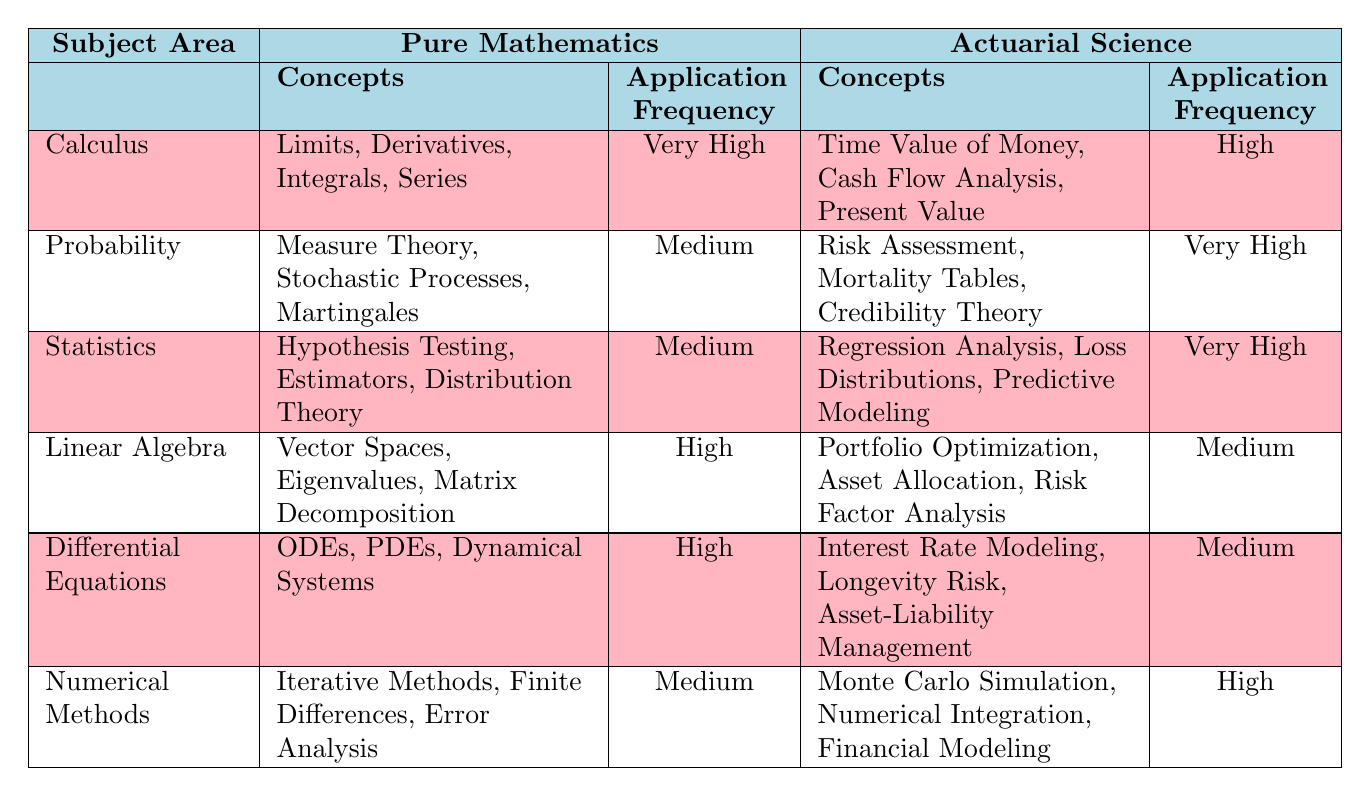What are the application frequencies of concepts in Probability under Pure Mathematics? In the table, the application frequency for concepts under the Probability subject area in Pure Mathematics is listed as "Medium."
Answer: Medium Which subject area in Actuarial Science has the highest application frequency? By examining the Actuarial Science section of the table, the Probability and Statistics areas both have an application frequency of "Very High," which is the highest among all others.
Answer: Probability and Statistics How many unique concepts are mentioned in the Calculus section under Actuarial Science? The table lists three unique concepts under the Actuarial Science section of Calculus: Time Value of Money, Cash Flow Analysis, and Present Value.
Answer: 3 What is the difference in application frequency between Statistics in Pure Mathematics and Statistics in Actuarial Science? Under Pure Mathematics, Statistics has an application frequency of "Medium," while under Actuarial Science, it has an application frequency of "Very High." The difference in frequency levels is one step up (Medium to Very High).
Answer: 1 step up Are there any concepts related to Linear Algebra that are not applicable to Actuarial Science? In the table, Linear Algebra under Pure Mathematics includes concepts such as Vector Spaces, Eigenvalues, and Matrix Decomposition, which do not have corresponding concepts listed under Actuarial Science. Thus, yes, there are concepts related to Linear Algebra in Pure Mathematics that are not applied in Actuarial Science.
Answer: Yes How does the application frequency of Numerical Methods in Actuarial Science compare to that of Linear Algebra? Numerical Methods has an application frequency of "High" in Actuarial Science, while Linear Algebra has a "Medium" application frequency. This indicates Numerical Methods is applied more frequently than Linear Algebra in Actuarial contexts.
Answer: Higher What is the total number of concepts listed in Pure Mathematics for all subject areas combined? Summing the number of concepts from Pure Mathematics: Calculus (4) + Probability (3) + Statistics (3) + Linear Algebra (3) + Differential Equations (3) + Numerical Methods (3) gives a total of 19 concepts.
Answer: 19 Is it true that all the concepts listed in Actuarial Science have a higher application frequency than those in Pure Mathematics? No, this statement is false because while Probability and Statistics in Actuarial Science have a "Very High" application frequency, some areas like Linear Algebra and Differential Equations in Actuarial Science have "Medium," which is lower than "High" and "Very High" of Pure Mathematics.
Answer: No 